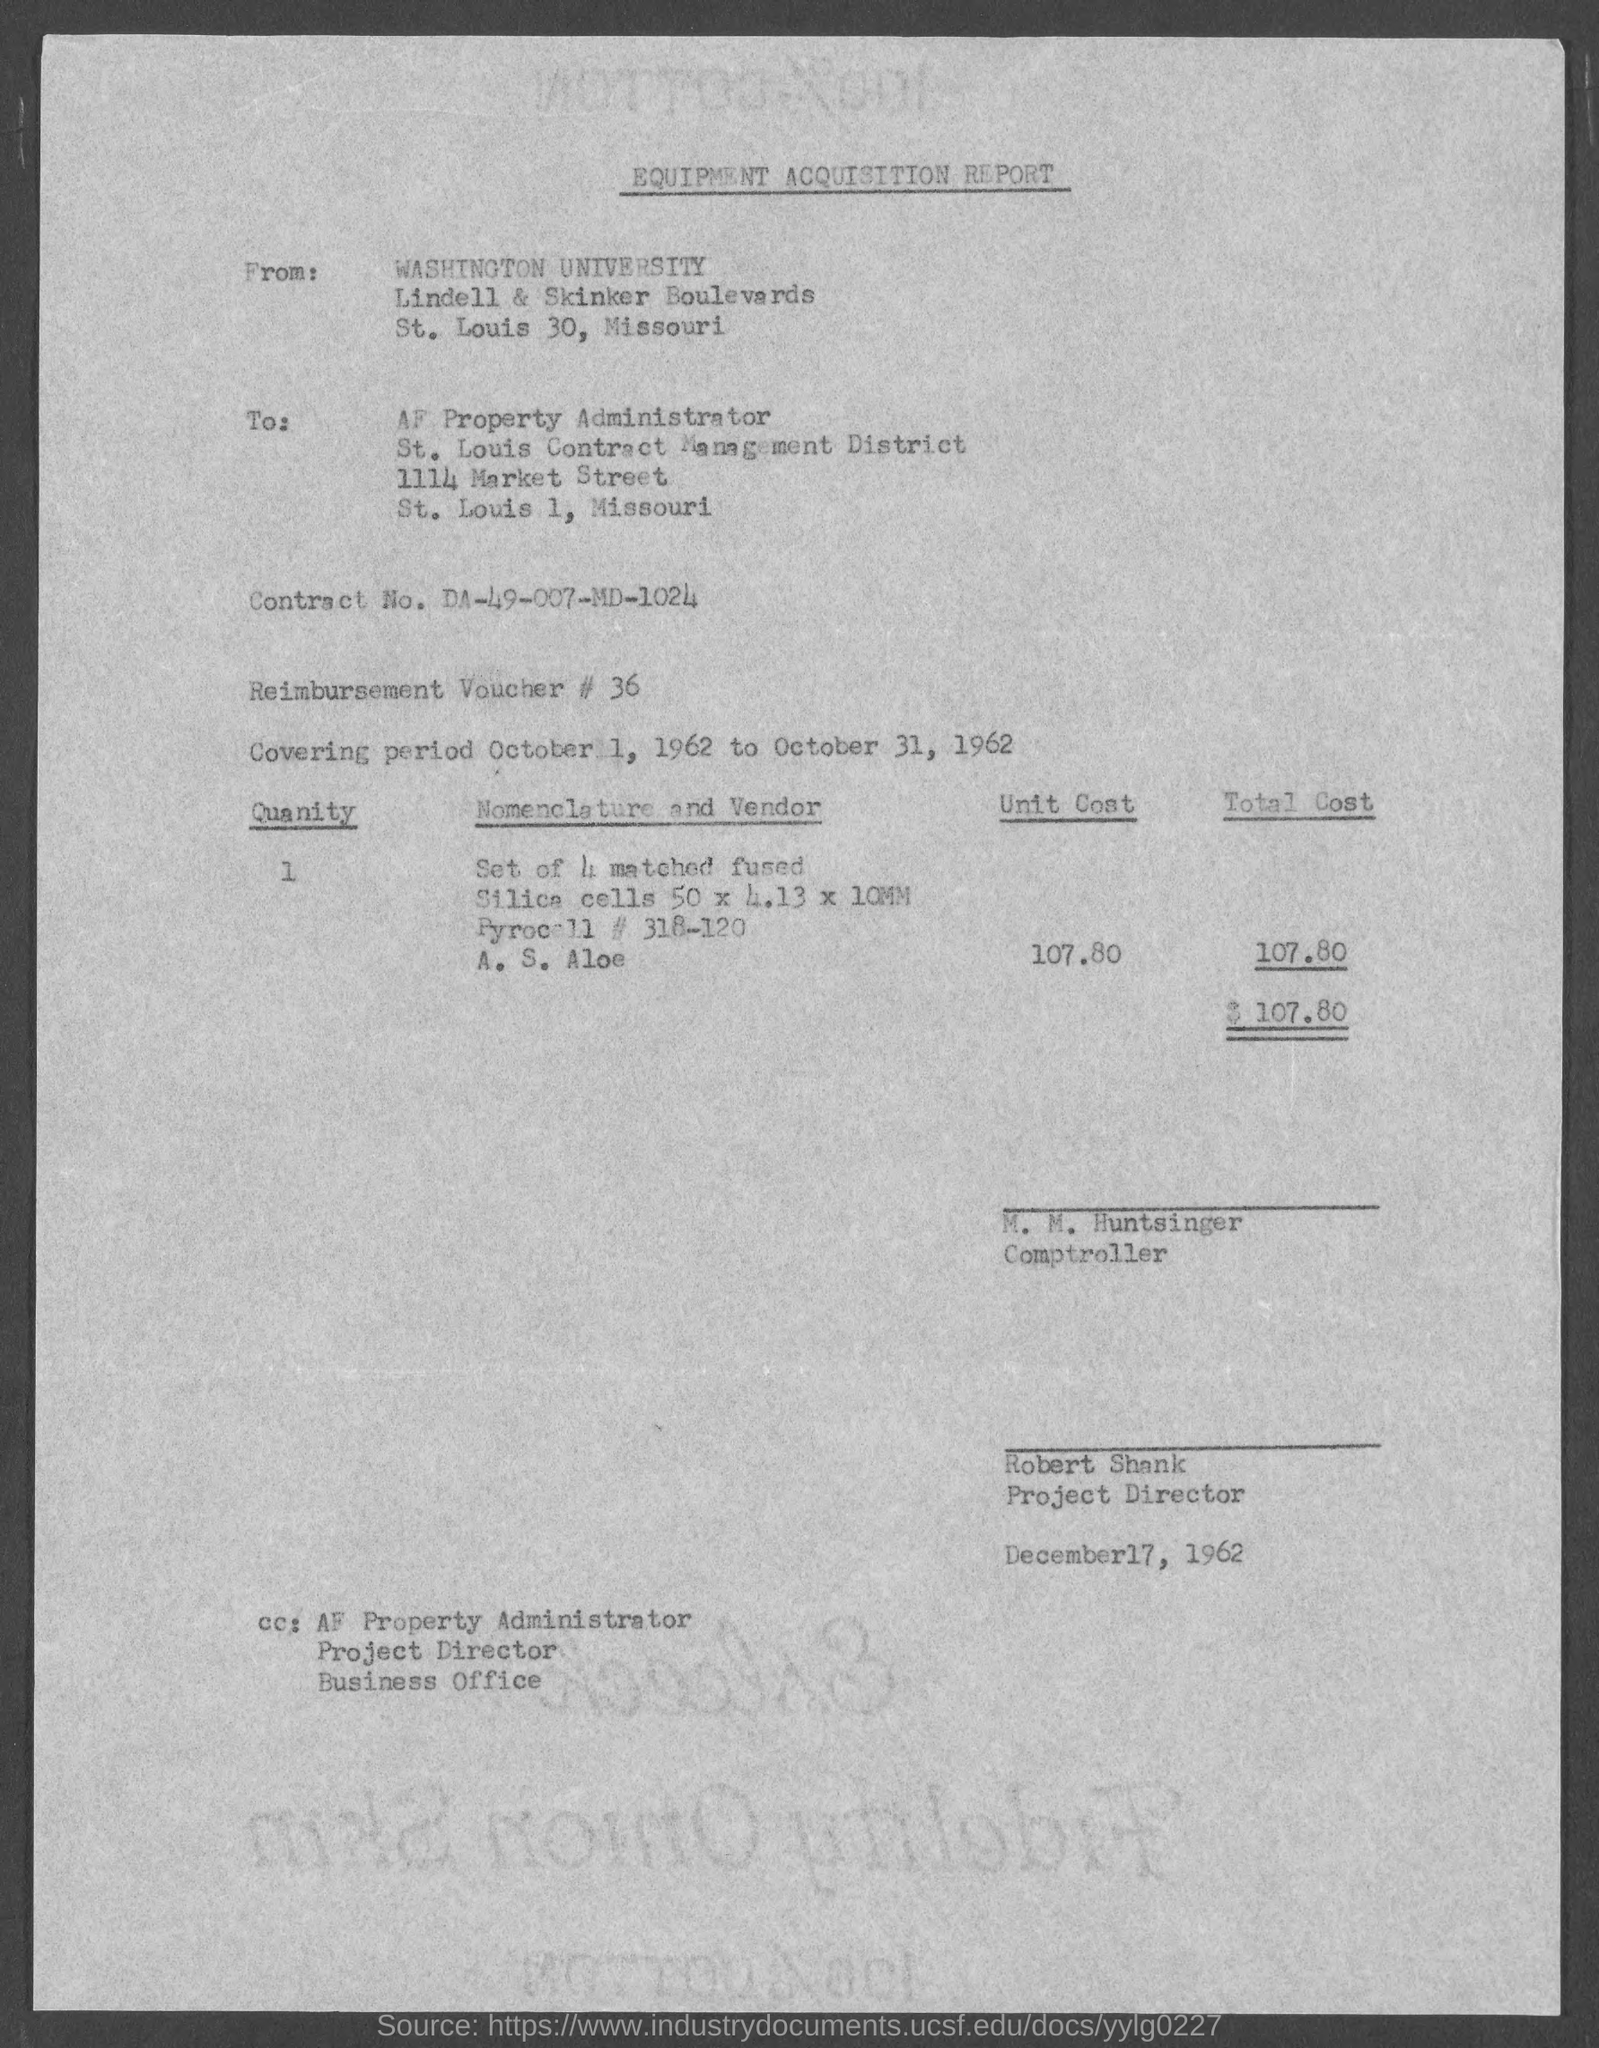What type of report is given here?
Keep it short and to the point. Equipment Acquisition Report. What is the Contract No. given in the report?
Make the answer very short. DA-49-007-MD-1024. What is the Reimbursement Voucher No. given in the report?
Provide a short and direct response. # 36. What is the covering period mentioned in the report?
Your answer should be compact. October 1, 1962 to October 31, 1962. What is the date mentioned in the equipment acquisition report?
Provide a short and direct response. December17, 1962. 